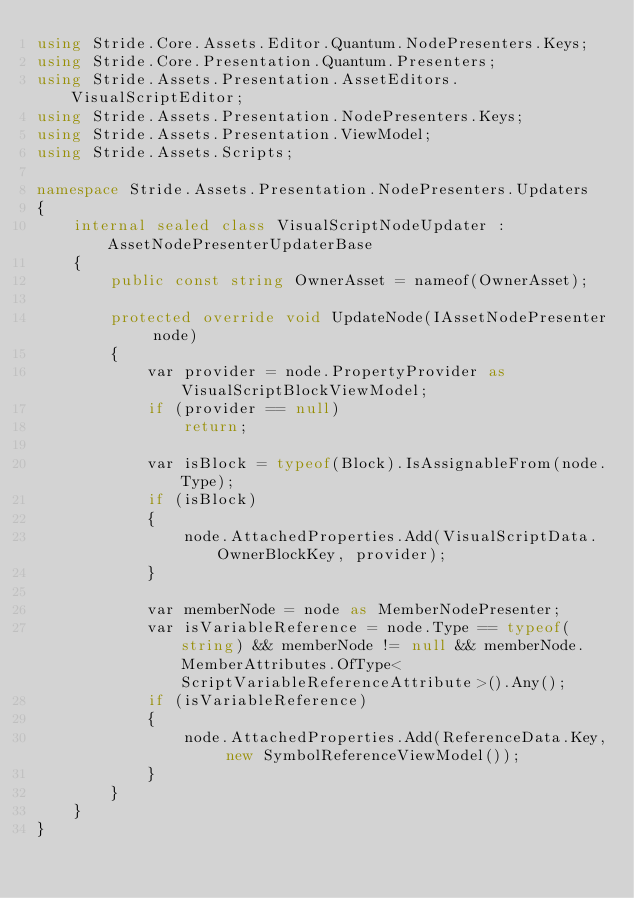<code> <loc_0><loc_0><loc_500><loc_500><_C#_>using Stride.Core.Assets.Editor.Quantum.NodePresenters.Keys;
using Stride.Core.Presentation.Quantum.Presenters;
using Stride.Assets.Presentation.AssetEditors.VisualScriptEditor;
using Stride.Assets.Presentation.NodePresenters.Keys;
using Stride.Assets.Presentation.ViewModel;
using Stride.Assets.Scripts;

namespace Stride.Assets.Presentation.NodePresenters.Updaters
{
    internal sealed class VisualScriptNodeUpdater : AssetNodePresenterUpdaterBase
    {
        public const string OwnerAsset = nameof(OwnerAsset);

        protected override void UpdateNode(IAssetNodePresenter node)
        {
            var provider = node.PropertyProvider as VisualScriptBlockViewModel;
            if (provider == null)
                return;

            var isBlock = typeof(Block).IsAssignableFrom(node.Type);
            if (isBlock)
            {
                node.AttachedProperties.Add(VisualScriptData.OwnerBlockKey, provider);
            }

            var memberNode = node as MemberNodePresenter;
            var isVariableReference = node.Type == typeof(string) && memberNode != null && memberNode.MemberAttributes.OfType<ScriptVariableReferenceAttribute>().Any();
            if (isVariableReference)
            {
                node.AttachedProperties.Add(ReferenceData.Key, new SymbolReferenceViewModel());
            }
        }
    }
}
</code> 